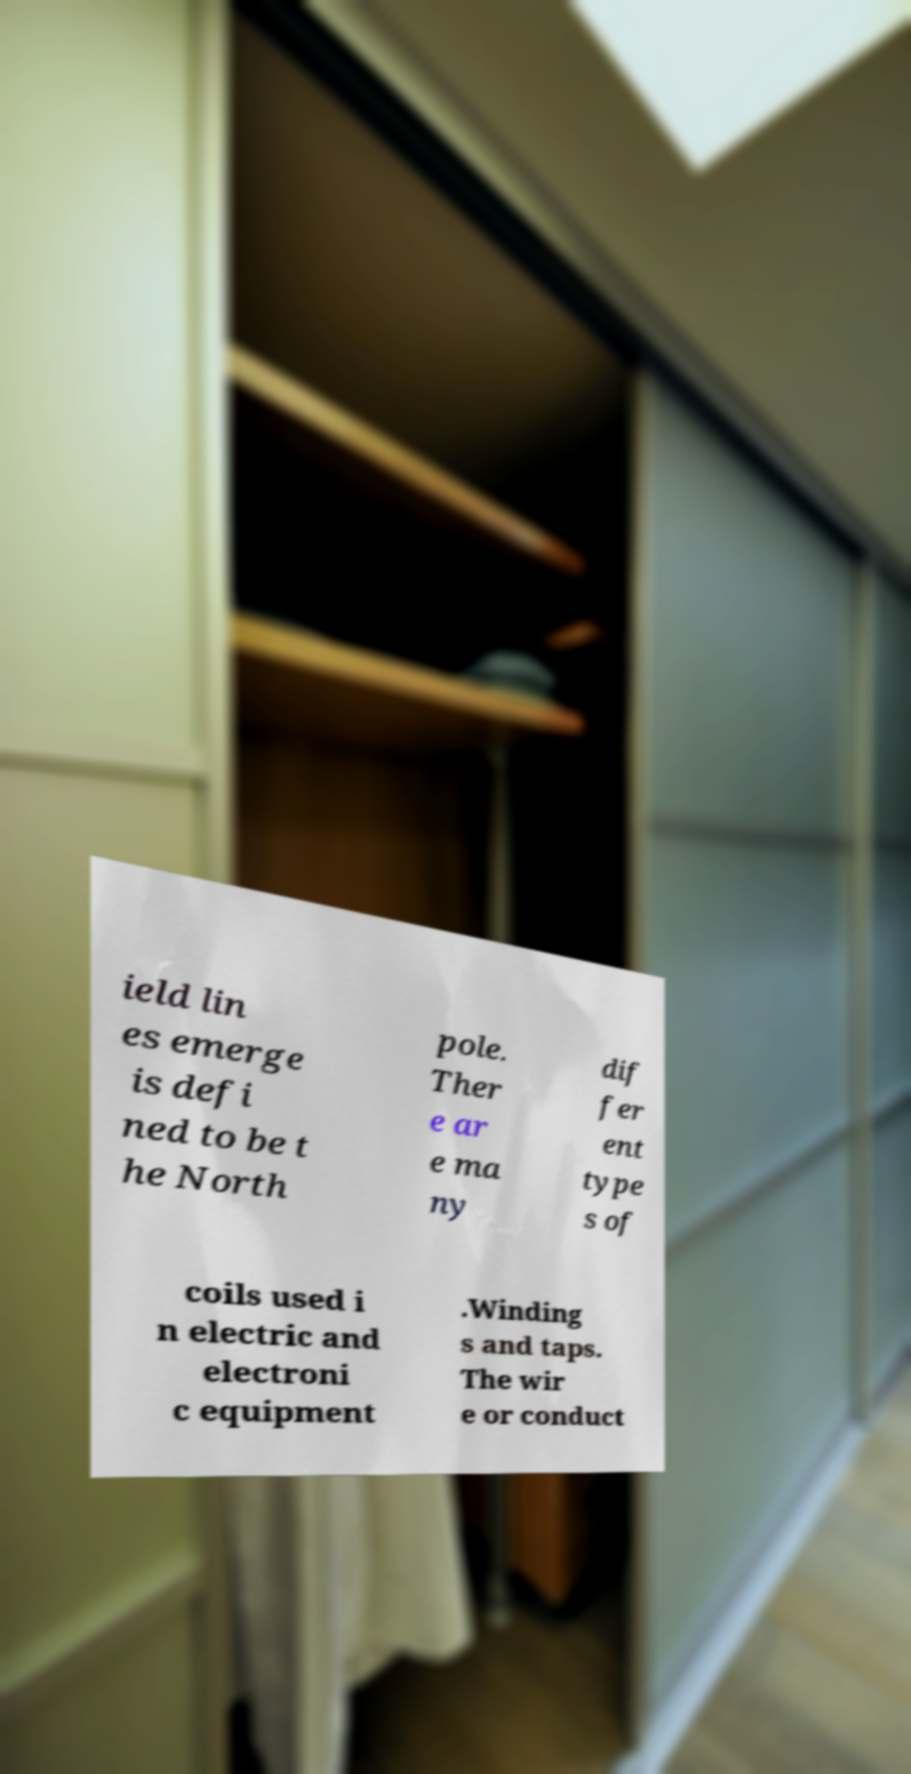Could you assist in decoding the text presented in this image and type it out clearly? ield lin es emerge is defi ned to be t he North pole. Ther e ar e ma ny dif fer ent type s of coils used i n electric and electroni c equipment .Winding s and taps. The wir e or conduct 